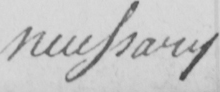Please transcribe the handwritten text in this image. necessary 